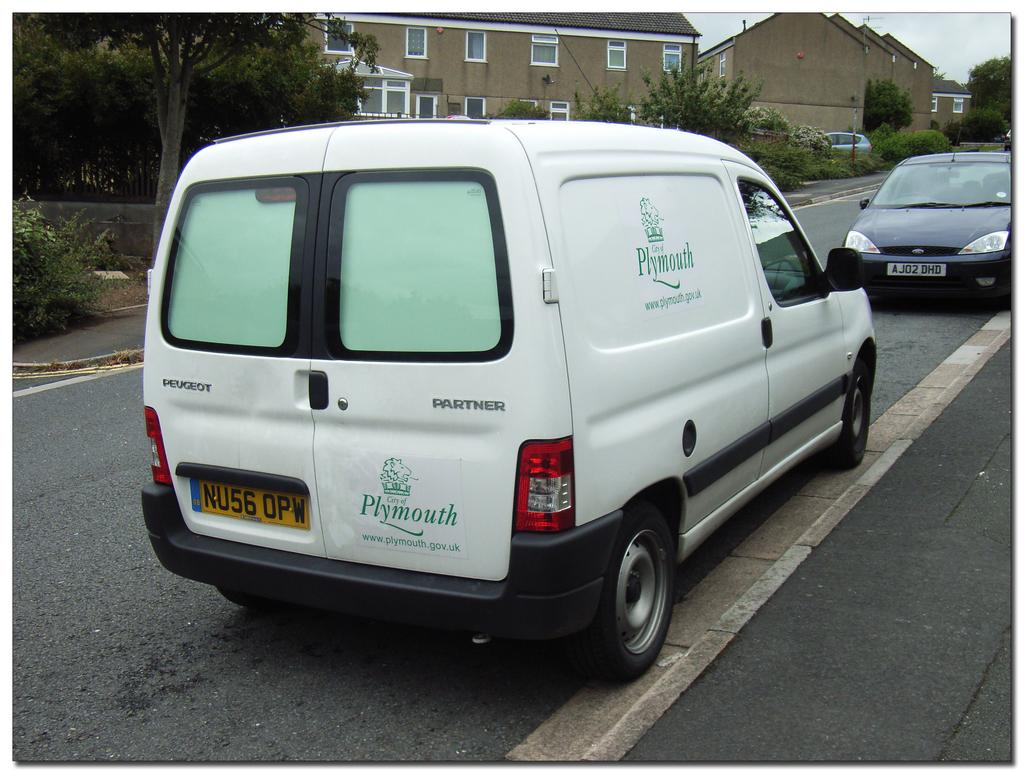<image>
Give a short and clear explanation of the subsequent image. A white van owned by the city of Plymouth is parked on the side of the road. 